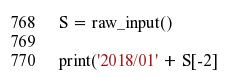<code> <loc_0><loc_0><loc_500><loc_500><_Python_>S = raw_input()

print('2018/01' + S[-2]</code> 